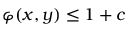Convert formula to latex. <formula><loc_0><loc_0><loc_500><loc_500>\varphi ( x , y ) \leq 1 + c</formula> 